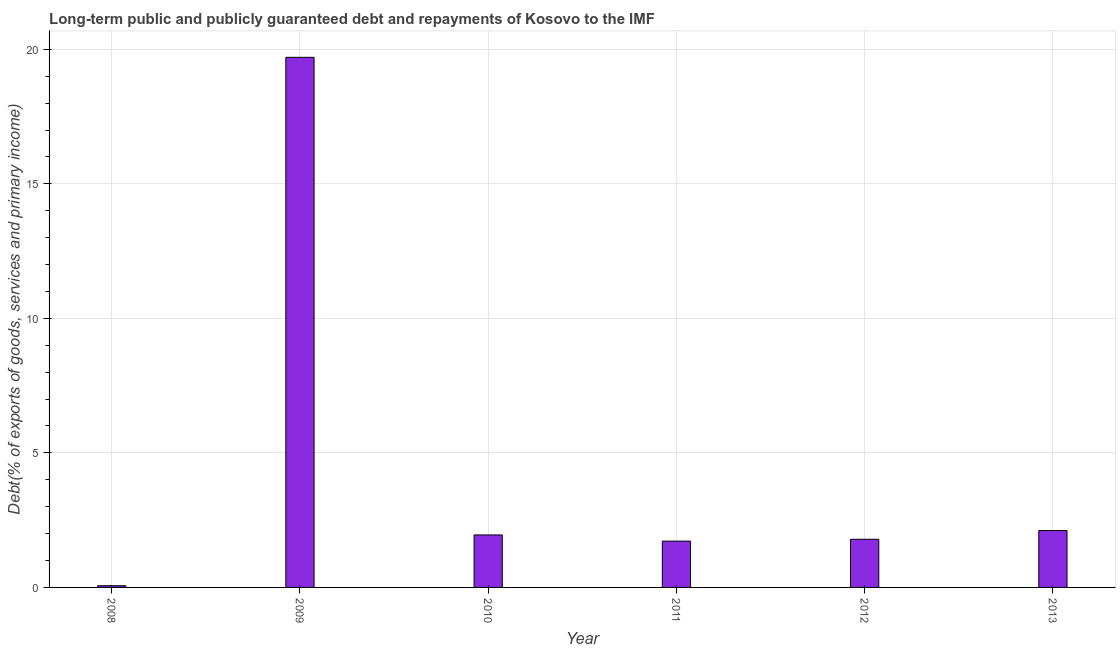Does the graph contain any zero values?
Make the answer very short. No. What is the title of the graph?
Give a very brief answer. Long-term public and publicly guaranteed debt and repayments of Kosovo to the IMF. What is the label or title of the X-axis?
Your answer should be compact. Year. What is the label or title of the Y-axis?
Your response must be concise. Debt(% of exports of goods, services and primary income). What is the debt service in 2010?
Ensure brevity in your answer.  1.95. Across all years, what is the maximum debt service?
Make the answer very short. 19.7. Across all years, what is the minimum debt service?
Your answer should be very brief. 0.06. In which year was the debt service maximum?
Make the answer very short. 2009. What is the sum of the debt service?
Your response must be concise. 27.34. What is the difference between the debt service in 2008 and 2012?
Give a very brief answer. -1.73. What is the average debt service per year?
Keep it short and to the point. 4.56. What is the median debt service?
Your answer should be very brief. 1.87. What is the ratio of the debt service in 2009 to that in 2011?
Ensure brevity in your answer.  11.45. Is the debt service in 2011 less than that in 2012?
Your response must be concise. Yes. What is the difference between the highest and the second highest debt service?
Your answer should be very brief. 17.59. Is the sum of the debt service in 2008 and 2010 greater than the maximum debt service across all years?
Your answer should be compact. No. What is the difference between the highest and the lowest debt service?
Provide a succinct answer. 19.64. How many years are there in the graph?
Provide a short and direct response. 6. Are the values on the major ticks of Y-axis written in scientific E-notation?
Provide a short and direct response. No. What is the Debt(% of exports of goods, services and primary income) in 2008?
Your response must be concise. 0.06. What is the Debt(% of exports of goods, services and primary income) of 2009?
Offer a terse response. 19.7. What is the Debt(% of exports of goods, services and primary income) of 2010?
Offer a very short reply. 1.95. What is the Debt(% of exports of goods, services and primary income) of 2011?
Your answer should be very brief. 1.72. What is the Debt(% of exports of goods, services and primary income) of 2012?
Provide a short and direct response. 1.79. What is the Debt(% of exports of goods, services and primary income) of 2013?
Your answer should be very brief. 2.12. What is the difference between the Debt(% of exports of goods, services and primary income) in 2008 and 2009?
Provide a short and direct response. -19.64. What is the difference between the Debt(% of exports of goods, services and primary income) in 2008 and 2010?
Ensure brevity in your answer.  -1.89. What is the difference between the Debt(% of exports of goods, services and primary income) in 2008 and 2011?
Give a very brief answer. -1.66. What is the difference between the Debt(% of exports of goods, services and primary income) in 2008 and 2012?
Keep it short and to the point. -1.73. What is the difference between the Debt(% of exports of goods, services and primary income) in 2008 and 2013?
Provide a short and direct response. -2.05. What is the difference between the Debt(% of exports of goods, services and primary income) in 2009 and 2010?
Your answer should be compact. 17.75. What is the difference between the Debt(% of exports of goods, services and primary income) in 2009 and 2011?
Make the answer very short. 17.98. What is the difference between the Debt(% of exports of goods, services and primary income) in 2009 and 2012?
Your answer should be very brief. 17.91. What is the difference between the Debt(% of exports of goods, services and primary income) in 2009 and 2013?
Your answer should be compact. 17.59. What is the difference between the Debt(% of exports of goods, services and primary income) in 2010 and 2011?
Your response must be concise. 0.23. What is the difference between the Debt(% of exports of goods, services and primary income) in 2010 and 2012?
Your answer should be very brief. 0.16. What is the difference between the Debt(% of exports of goods, services and primary income) in 2010 and 2013?
Make the answer very short. -0.16. What is the difference between the Debt(% of exports of goods, services and primary income) in 2011 and 2012?
Your response must be concise. -0.07. What is the difference between the Debt(% of exports of goods, services and primary income) in 2011 and 2013?
Offer a terse response. -0.39. What is the difference between the Debt(% of exports of goods, services and primary income) in 2012 and 2013?
Offer a very short reply. -0.33. What is the ratio of the Debt(% of exports of goods, services and primary income) in 2008 to that in 2009?
Provide a succinct answer. 0. What is the ratio of the Debt(% of exports of goods, services and primary income) in 2008 to that in 2010?
Your response must be concise. 0.03. What is the ratio of the Debt(% of exports of goods, services and primary income) in 2008 to that in 2011?
Provide a short and direct response. 0.04. What is the ratio of the Debt(% of exports of goods, services and primary income) in 2008 to that in 2012?
Offer a terse response. 0.04. What is the ratio of the Debt(% of exports of goods, services and primary income) in 2009 to that in 2011?
Provide a short and direct response. 11.45. What is the ratio of the Debt(% of exports of goods, services and primary income) in 2009 to that in 2012?
Ensure brevity in your answer.  11.01. What is the ratio of the Debt(% of exports of goods, services and primary income) in 2009 to that in 2013?
Give a very brief answer. 9.31. What is the ratio of the Debt(% of exports of goods, services and primary income) in 2010 to that in 2011?
Ensure brevity in your answer.  1.13. What is the ratio of the Debt(% of exports of goods, services and primary income) in 2010 to that in 2012?
Make the answer very short. 1.09. What is the ratio of the Debt(% of exports of goods, services and primary income) in 2010 to that in 2013?
Ensure brevity in your answer.  0.92. What is the ratio of the Debt(% of exports of goods, services and primary income) in 2011 to that in 2013?
Keep it short and to the point. 0.81. What is the ratio of the Debt(% of exports of goods, services and primary income) in 2012 to that in 2013?
Make the answer very short. 0.85. 